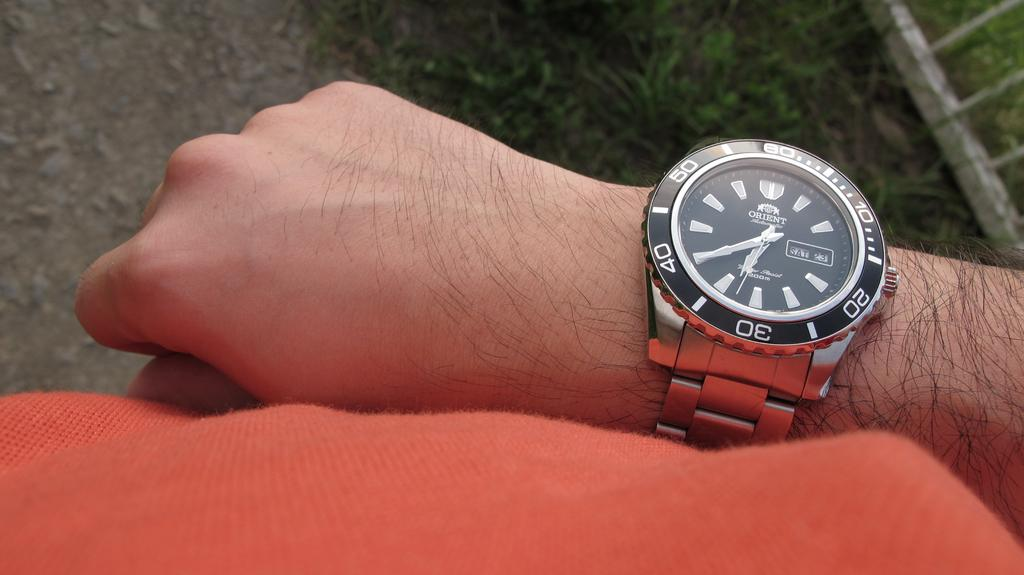<image>
Create a compact narrative representing the image presented. An Orient brand watch says that today is Saturday. 